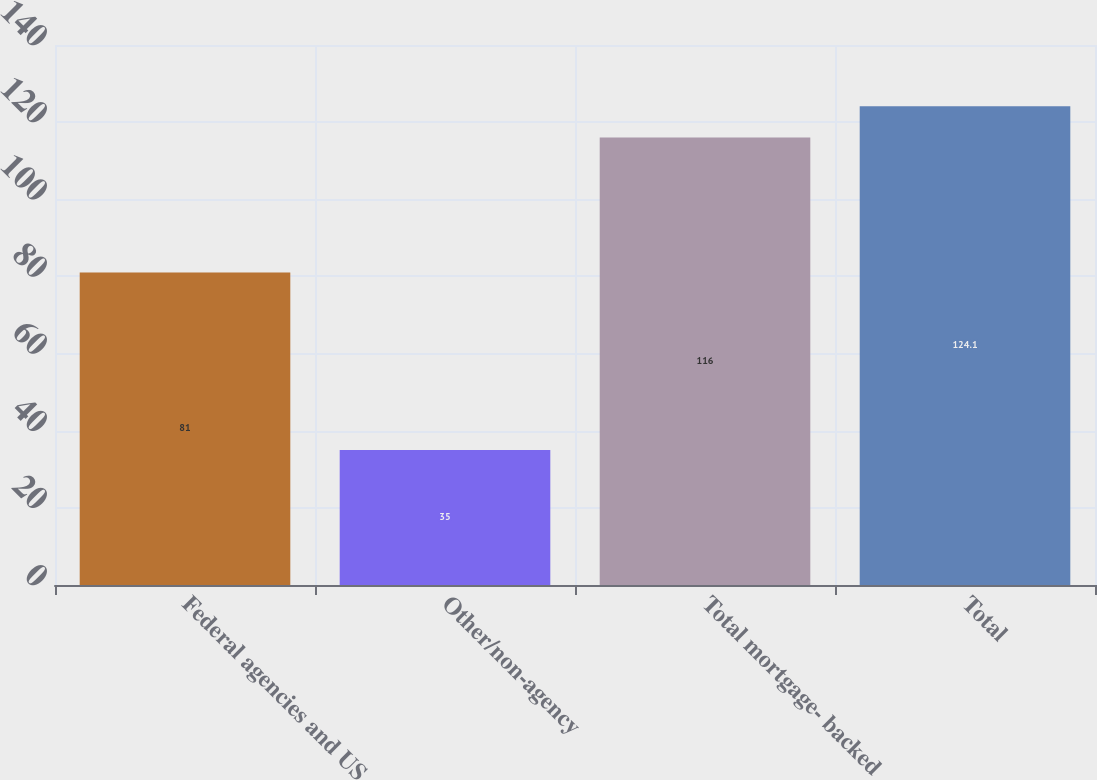Convert chart. <chart><loc_0><loc_0><loc_500><loc_500><bar_chart><fcel>Federal agencies and US<fcel>Other/non-agency<fcel>Total mortgage- backed<fcel>Total<nl><fcel>81<fcel>35<fcel>116<fcel>124.1<nl></chart> 